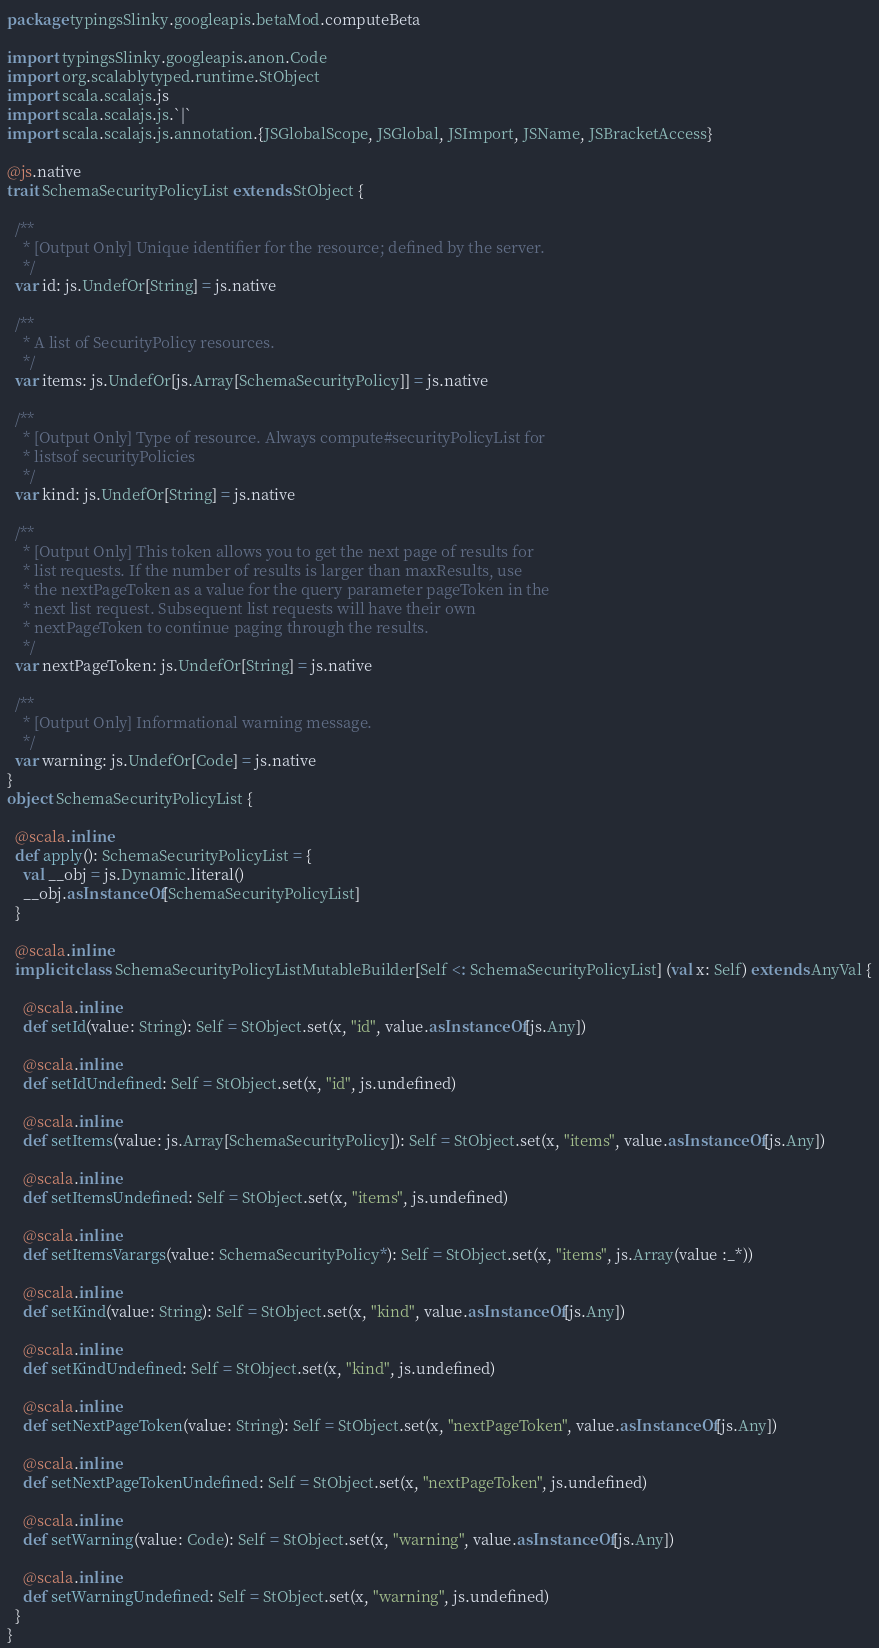<code> <loc_0><loc_0><loc_500><loc_500><_Scala_>package typingsSlinky.googleapis.betaMod.computeBeta

import typingsSlinky.googleapis.anon.Code
import org.scalablytyped.runtime.StObject
import scala.scalajs.js
import scala.scalajs.js.`|`
import scala.scalajs.js.annotation.{JSGlobalScope, JSGlobal, JSImport, JSName, JSBracketAccess}

@js.native
trait SchemaSecurityPolicyList extends StObject {
  
  /**
    * [Output Only] Unique identifier for the resource; defined by the server.
    */
  var id: js.UndefOr[String] = js.native
  
  /**
    * A list of SecurityPolicy resources.
    */
  var items: js.UndefOr[js.Array[SchemaSecurityPolicy]] = js.native
  
  /**
    * [Output Only] Type of resource. Always compute#securityPolicyList for
    * listsof securityPolicies
    */
  var kind: js.UndefOr[String] = js.native
  
  /**
    * [Output Only] This token allows you to get the next page of results for
    * list requests. If the number of results is larger than maxResults, use
    * the nextPageToken as a value for the query parameter pageToken in the
    * next list request. Subsequent list requests will have their own
    * nextPageToken to continue paging through the results.
    */
  var nextPageToken: js.UndefOr[String] = js.native
  
  /**
    * [Output Only] Informational warning message.
    */
  var warning: js.UndefOr[Code] = js.native
}
object SchemaSecurityPolicyList {
  
  @scala.inline
  def apply(): SchemaSecurityPolicyList = {
    val __obj = js.Dynamic.literal()
    __obj.asInstanceOf[SchemaSecurityPolicyList]
  }
  
  @scala.inline
  implicit class SchemaSecurityPolicyListMutableBuilder[Self <: SchemaSecurityPolicyList] (val x: Self) extends AnyVal {
    
    @scala.inline
    def setId(value: String): Self = StObject.set(x, "id", value.asInstanceOf[js.Any])
    
    @scala.inline
    def setIdUndefined: Self = StObject.set(x, "id", js.undefined)
    
    @scala.inline
    def setItems(value: js.Array[SchemaSecurityPolicy]): Self = StObject.set(x, "items", value.asInstanceOf[js.Any])
    
    @scala.inline
    def setItemsUndefined: Self = StObject.set(x, "items", js.undefined)
    
    @scala.inline
    def setItemsVarargs(value: SchemaSecurityPolicy*): Self = StObject.set(x, "items", js.Array(value :_*))
    
    @scala.inline
    def setKind(value: String): Self = StObject.set(x, "kind", value.asInstanceOf[js.Any])
    
    @scala.inline
    def setKindUndefined: Self = StObject.set(x, "kind", js.undefined)
    
    @scala.inline
    def setNextPageToken(value: String): Self = StObject.set(x, "nextPageToken", value.asInstanceOf[js.Any])
    
    @scala.inline
    def setNextPageTokenUndefined: Self = StObject.set(x, "nextPageToken", js.undefined)
    
    @scala.inline
    def setWarning(value: Code): Self = StObject.set(x, "warning", value.asInstanceOf[js.Any])
    
    @scala.inline
    def setWarningUndefined: Self = StObject.set(x, "warning", js.undefined)
  }
}
</code> 